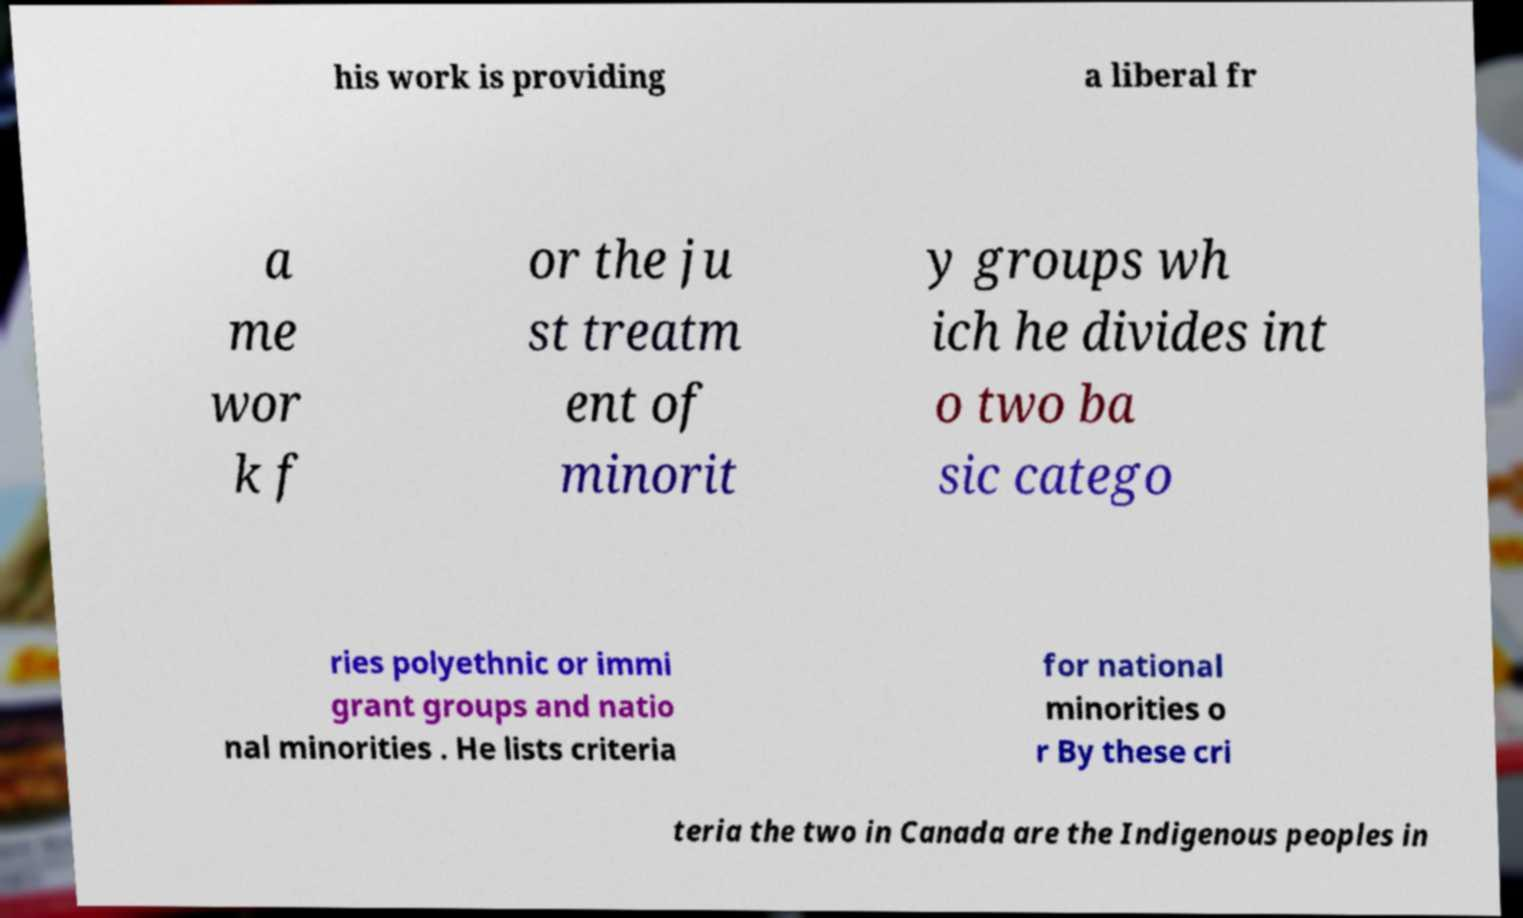What messages or text are displayed in this image? I need them in a readable, typed format. his work is providing a liberal fr a me wor k f or the ju st treatm ent of minorit y groups wh ich he divides int o two ba sic catego ries polyethnic or immi grant groups and natio nal minorities . He lists criteria for national minorities o r By these cri teria the two in Canada are the Indigenous peoples in 